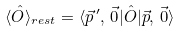<formula> <loc_0><loc_0><loc_500><loc_500>\langle \hat { O } \rangle _ { r e s t } = \langle \vec { p } ^ { \, \prime } , \, \vec { 0 } | \hat { O } | \vec { p } , \, \vec { 0 } \rangle</formula> 